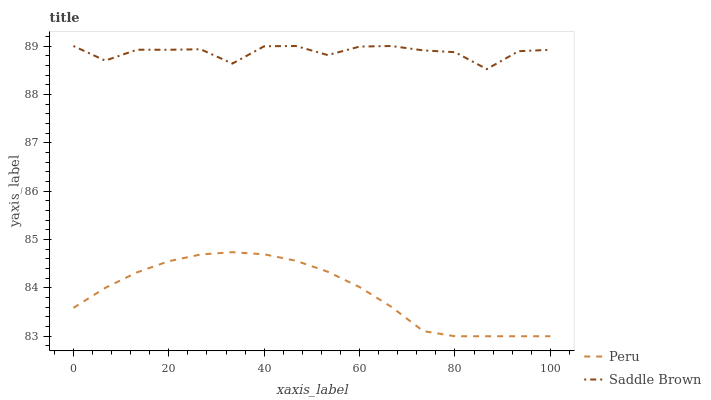Does Peru have the minimum area under the curve?
Answer yes or no. Yes. Does Saddle Brown have the maximum area under the curve?
Answer yes or no. Yes. Does Peru have the maximum area under the curve?
Answer yes or no. No. Is Peru the smoothest?
Answer yes or no. Yes. Is Saddle Brown the roughest?
Answer yes or no. Yes. Is Peru the roughest?
Answer yes or no. No. Does Peru have the lowest value?
Answer yes or no. Yes. Does Saddle Brown have the highest value?
Answer yes or no. Yes. Does Peru have the highest value?
Answer yes or no. No. Is Peru less than Saddle Brown?
Answer yes or no. Yes. Is Saddle Brown greater than Peru?
Answer yes or no. Yes. Does Peru intersect Saddle Brown?
Answer yes or no. No. 